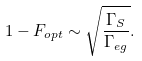<formula> <loc_0><loc_0><loc_500><loc_500>1 - F _ { o p t } \sim \sqrt { \frac { \Gamma _ { S } } { \Gamma _ { e g } } } .</formula> 